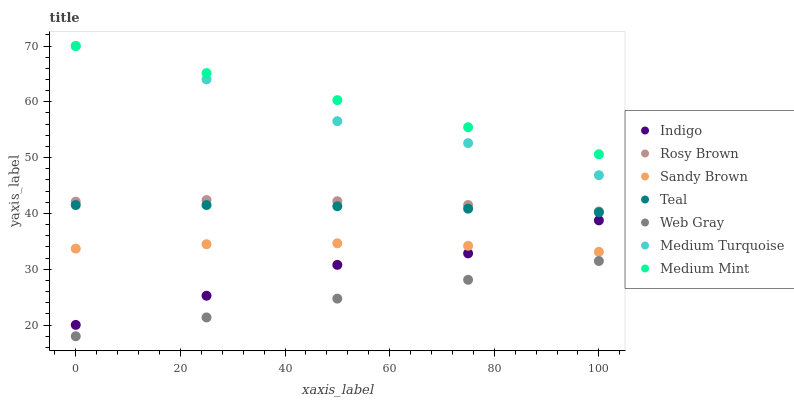Does Web Gray have the minimum area under the curve?
Answer yes or no. Yes. Does Medium Mint have the maximum area under the curve?
Answer yes or no. Yes. Does Indigo have the minimum area under the curve?
Answer yes or no. No. Does Indigo have the maximum area under the curve?
Answer yes or no. No. Is Web Gray the smoothest?
Answer yes or no. Yes. Is Indigo the roughest?
Answer yes or no. Yes. Is Indigo the smoothest?
Answer yes or no. No. Is Web Gray the roughest?
Answer yes or no. No. Does Web Gray have the lowest value?
Answer yes or no. Yes. Does Indigo have the lowest value?
Answer yes or no. No. Does Medium Turquoise have the highest value?
Answer yes or no. Yes. Does Indigo have the highest value?
Answer yes or no. No. Is Web Gray less than Indigo?
Answer yes or no. Yes. Is Medium Turquoise greater than Web Gray?
Answer yes or no. Yes. Does Sandy Brown intersect Indigo?
Answer yes or no. Yes. Is Sandy Brown less than Indigo?
Answer yes or no. No. Is Sandy Brown greater than Indigo?
Answer yes or no. No. Does Web Gray intersect Indigo?
Answer yes or no. No. 